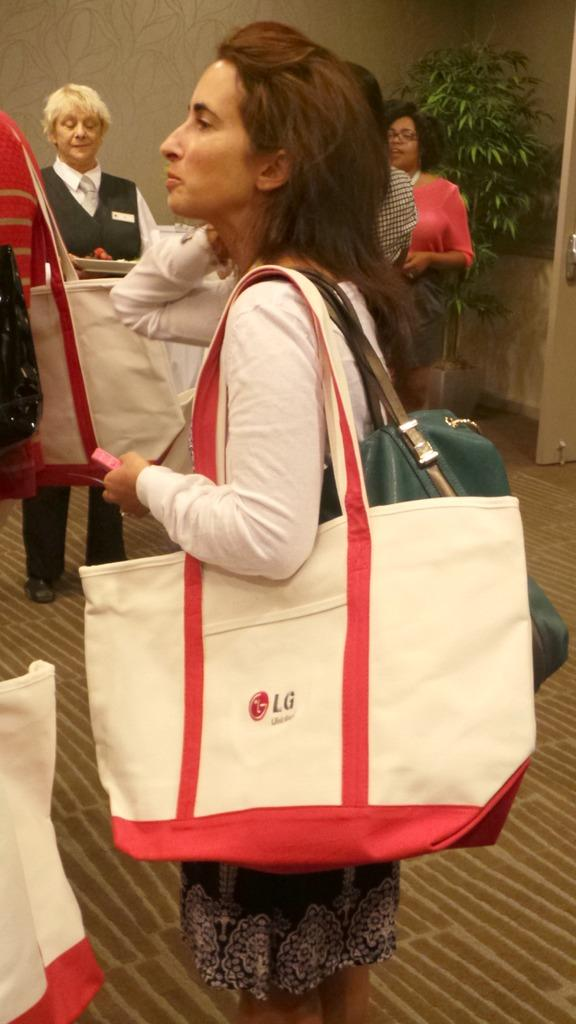What is the woman in the image doing? The woman is standing in the image and carrying bags. Can you describe the background of the image? There are people, a wall, and a plant in the background of the image. What type of mine can be seen in the background of the image? There is no mine present in the image; it features a woman standing with bags and a background that includes people, a wall, and a plant. 